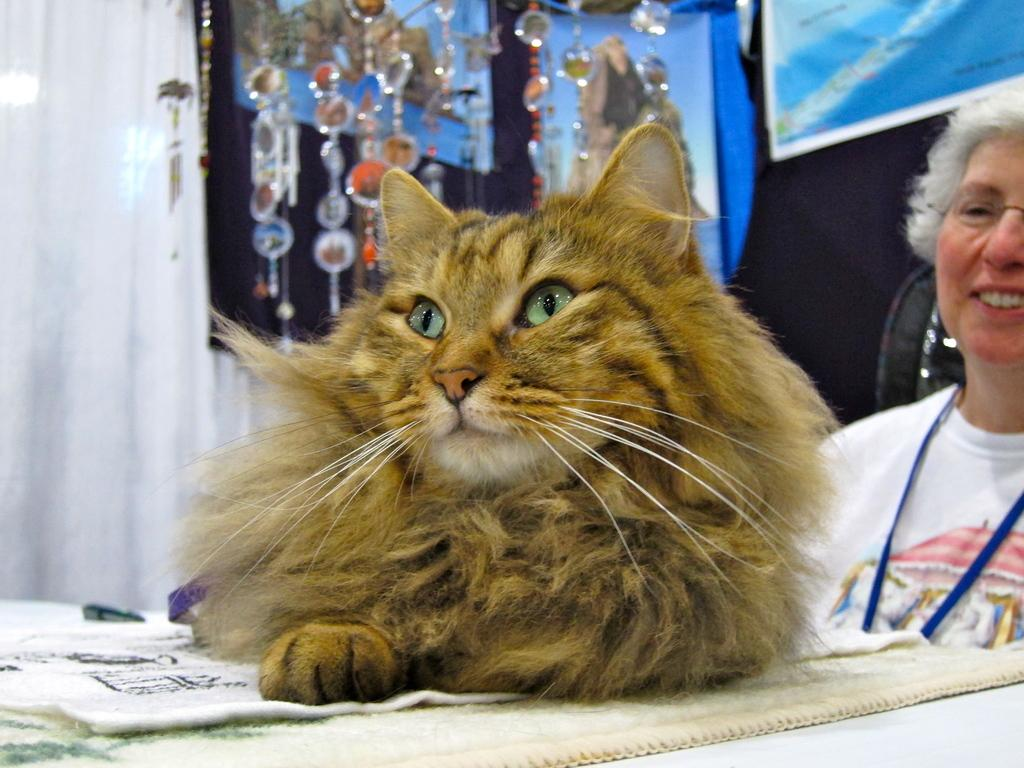Who is present in the image? There is a woman in the image. What type of animal is also present in the image? There is a cat in the image. What can be seen in the background of the image? There is a poster and additional objects visible in the background of the image. What type of stew is being prepared in the image? There is no stew present in the image. How many ants can be seen crawling on the woman's arm in the image? There are no ants visible in the image. 